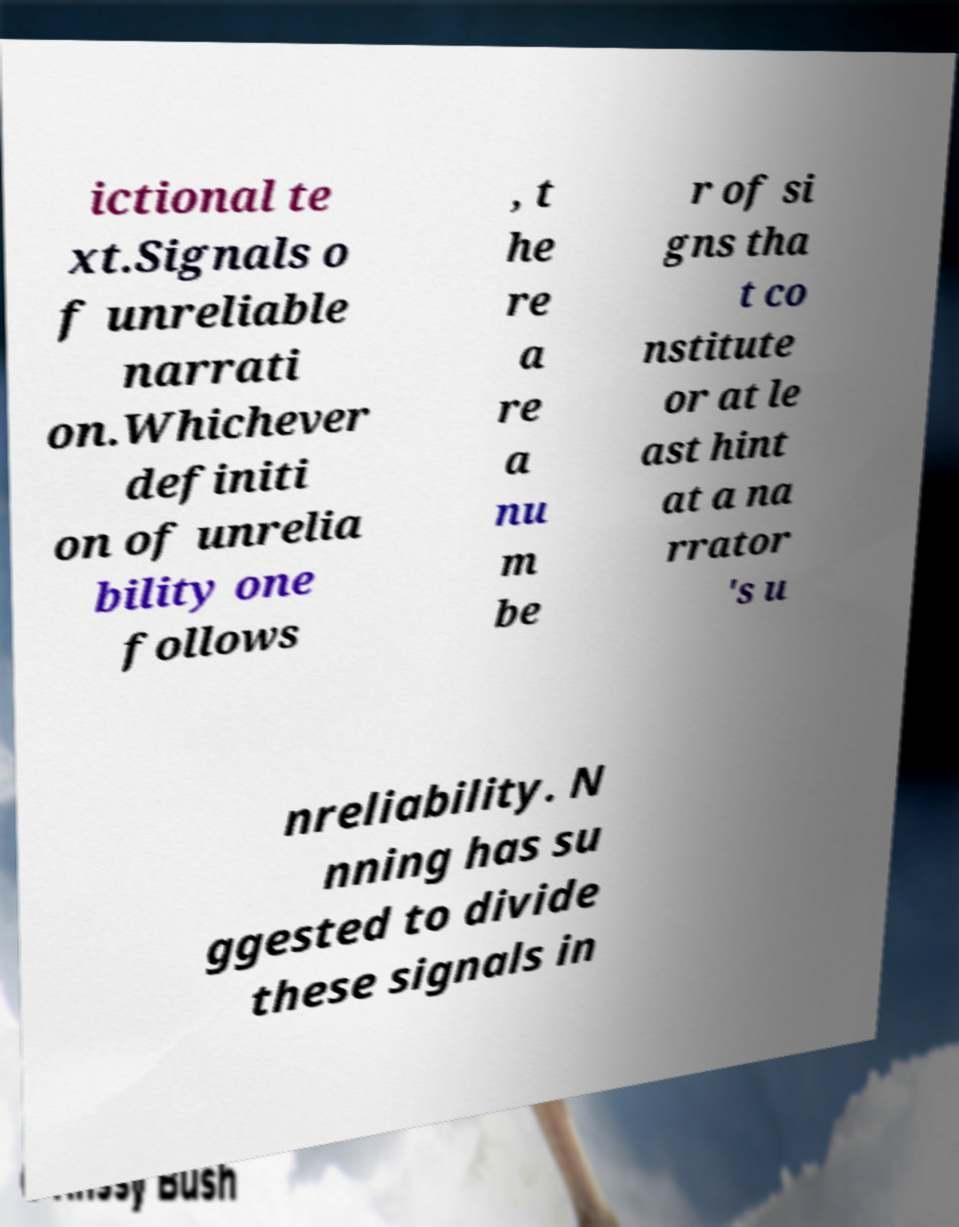Please identify and transcribe the text found in this image. ictional te xt.Signals o f unreliable narrati on.Whichever definiti on of unrelia bility one follows , t he re a re a nu m be r of si gns tha t co nstitute or at le ast hint at a na rrator 's u nreliability. N nning has su ggested to divide these signals in 